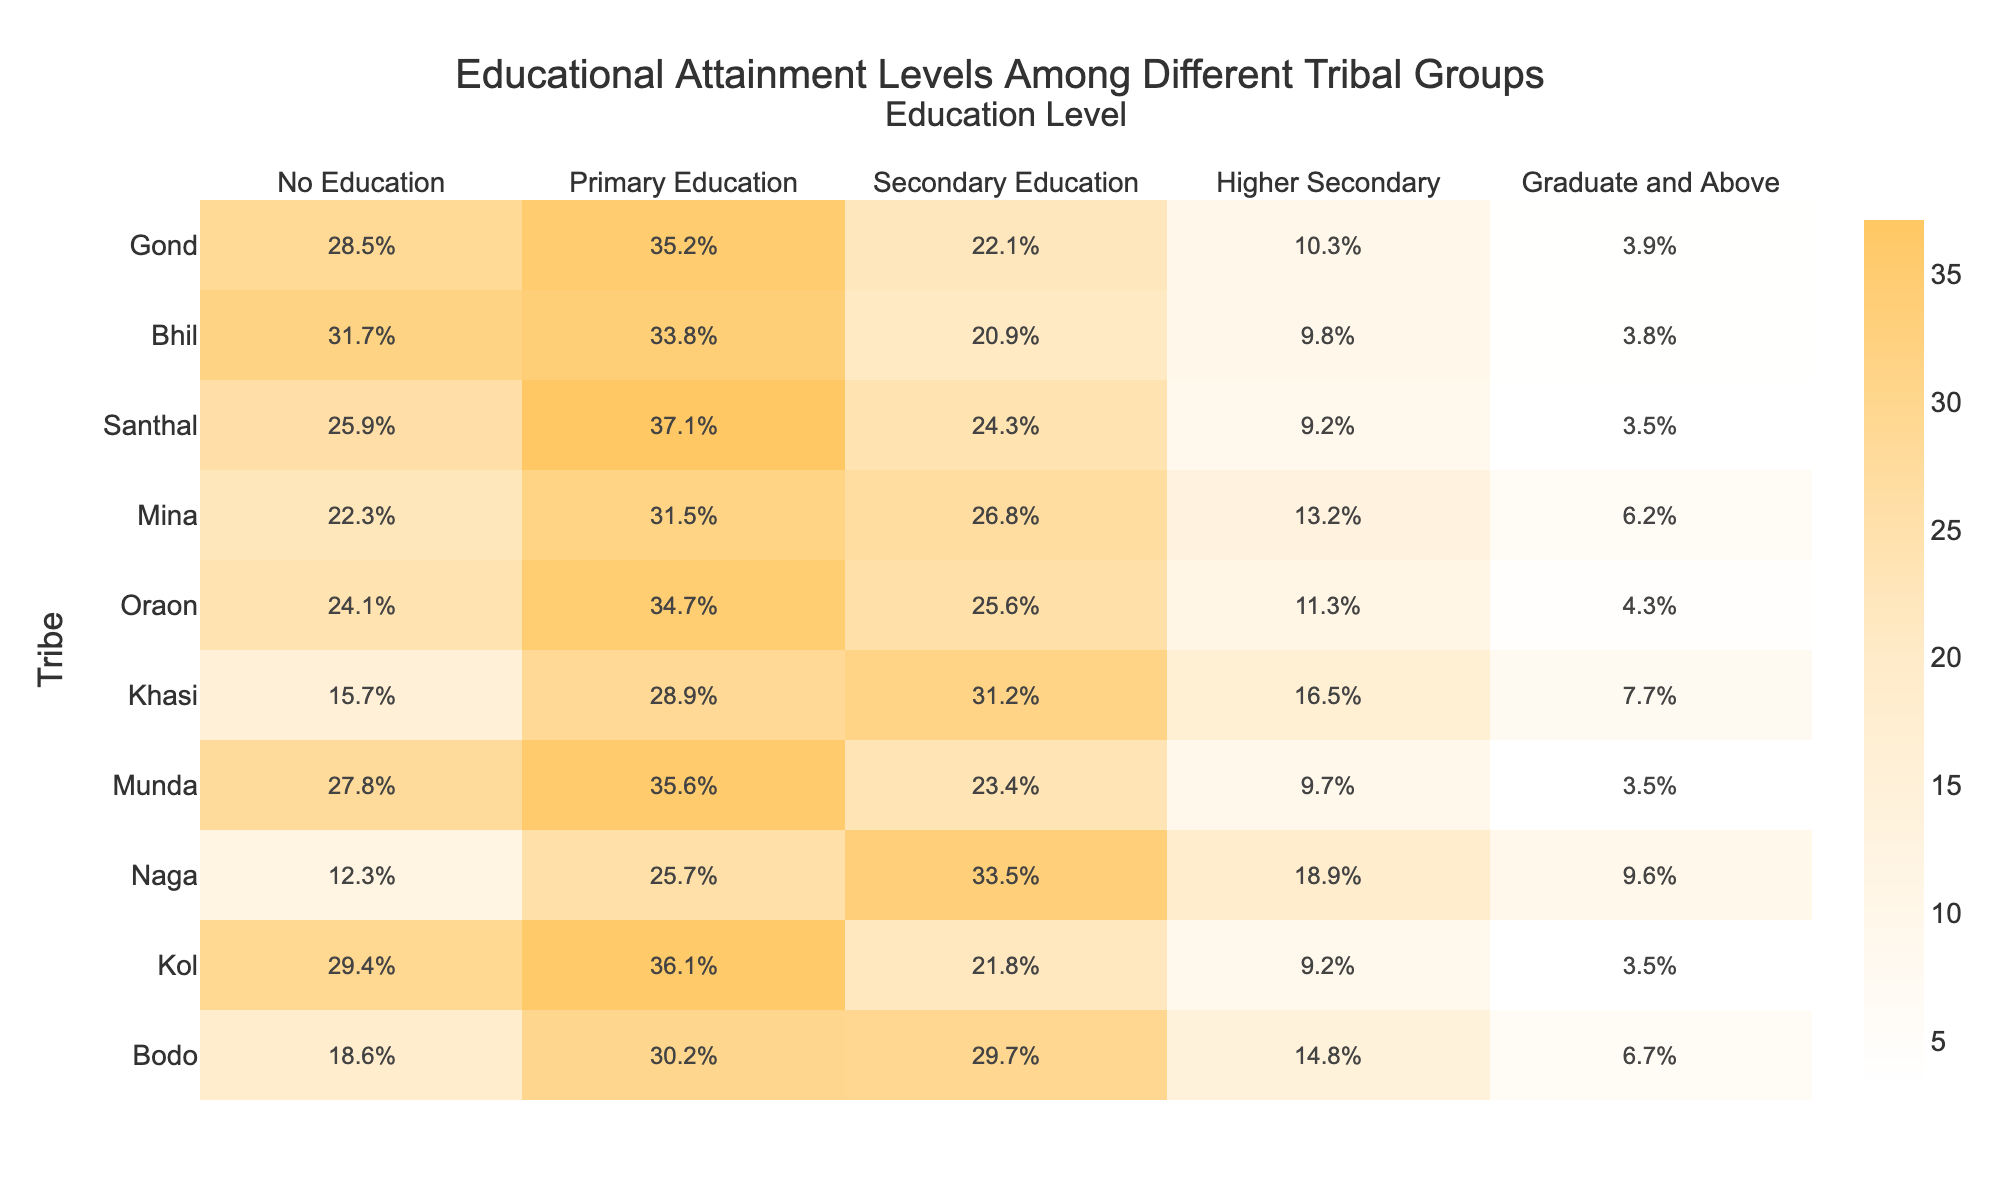What percentage of Gond tribe has no education? The table shows that the percentage of the Gond tribe with no education is indicated in the "No Education" column, which is 28.5%.
Answer: 28.5% Which tribe has the highest percentage of individuals with graduate and above education? By looking at the "Graduate and Above" column, we see that the Mina tribe has the highest percentage at 6.2%.
Answer: 6.2% What is the average percentage of secondary education across all tribes? The secondary education percentages for each tribe are added together (22.1 + 20.9 + 24.3 + 26.8 + 25.6 + 31.2 + 23.4 + 33.5 + 21.8 + 29.7 =  259.2), then divided by the number of tribes (10), giving us an average of 25.92%.
Answer: 25.9% Which tribe has the lowest percentage of individuals with higher secondary education? By comparing the values in the "Higher Secondary" column, the Bhil tribe has the lowest percentage at 9.8%.
Answer: 9.8% Does the Santhal tribe have a higher percentage of individuals with primary education than the Munda tribe? Checking the "Primary Education" column, Santhal has 37.1% while Munda has 35.6%. Since 37.1% is greater than 35.6%, the statement is true.
Answer: Yes What percentage difference in no education exists between the Khasi and the Bodo tribes? The percentage of no education for Khasi is 15.7% and for Bodo is 18.6%. To find the difference we subtract: 18.6% - 15.7% = 2.9%.
Answer: 2.9% If we combine the percentages of graduate and above for all tribes, what is the total percentage? Adding the percentages in the "Graduate and Above" column results in (3.9 + 3.8 + 3.5 + 6.2 + 4.3 + 7.7 + 3.5 + 9.6 + 3.5 + 6.7 = 51.7%).
Answer: 51.7% What is the ratio of primary education to no education for the Naga tribe? The ratio is obtained by comparing the percentages in the respective columns: Primary Education is 25.7% and No Education is 12.3%. The ratio is thus 25.7:12.3, which simplifies to approximately 2.09:1.
Answer: 2.09:1 Which tribal group has a higher percentage of secondary than higher secondary education? By inspecting the "Secondary Education" and "Higher Secondary" columns, the tribes that satisfy this condition are Gond, Bhil, Santhal, Oraon, Munda, and Kol since their secondary percentages are higher than their higher secondary percentages.
Answer: Multiple tribes What is the total percentage of individuals who have secondary education or below across all tribes? First, we calculate the total for "No Education", "Primary Education", and "Secondary Education": 28.5 + 31.7 + 25.9 + 22.3 + 24.1 + 15.7 + 27.8 + 12.3 + 29.4 + 18.6 =  334.1%, then divide by 10 to find the average: 334.1% / 10 = 33.41%.
Answer: 33.41% 